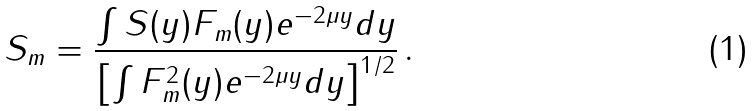<formula> <loc_0><loc_0><loc_500><loc_500>S _ { m } = \frac { \int S ( y ) F _ { m } ( y ) e ^ { - 2 \mu y } d y } { \left [ \int F _ { m } ^ { 2 } ( y ) e ^ { - 2 \mu y } d y \right ] ^ { 1 / 2 } } \, .</formula> 